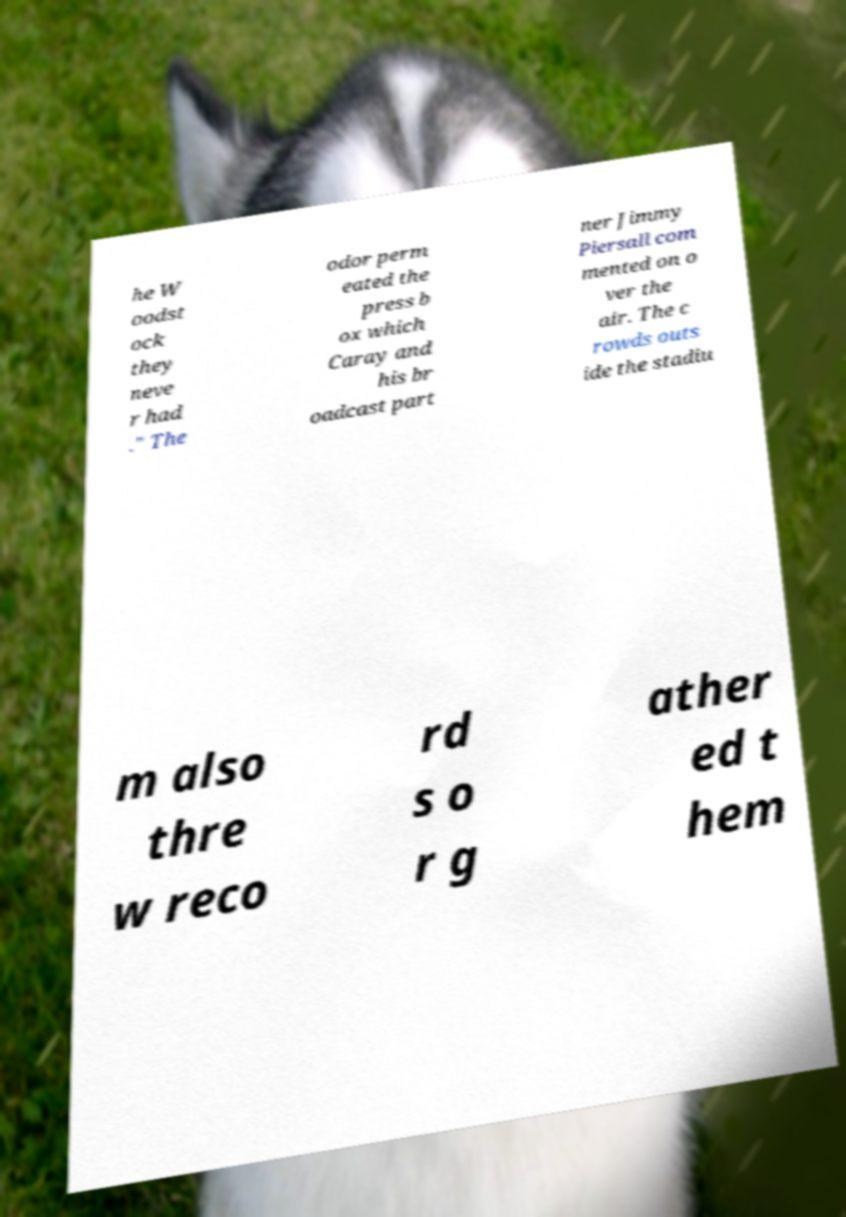Could you extract and type out the text from this image? he W oodst ock they neve r had ." The odor perm eated the press b ox which Caray and his br oadcast part ner Jimmy Piersall com mented on o ver the air. The c rowds outs ide the stadiu m also thre w reco rd s o r g ather ed t hem 